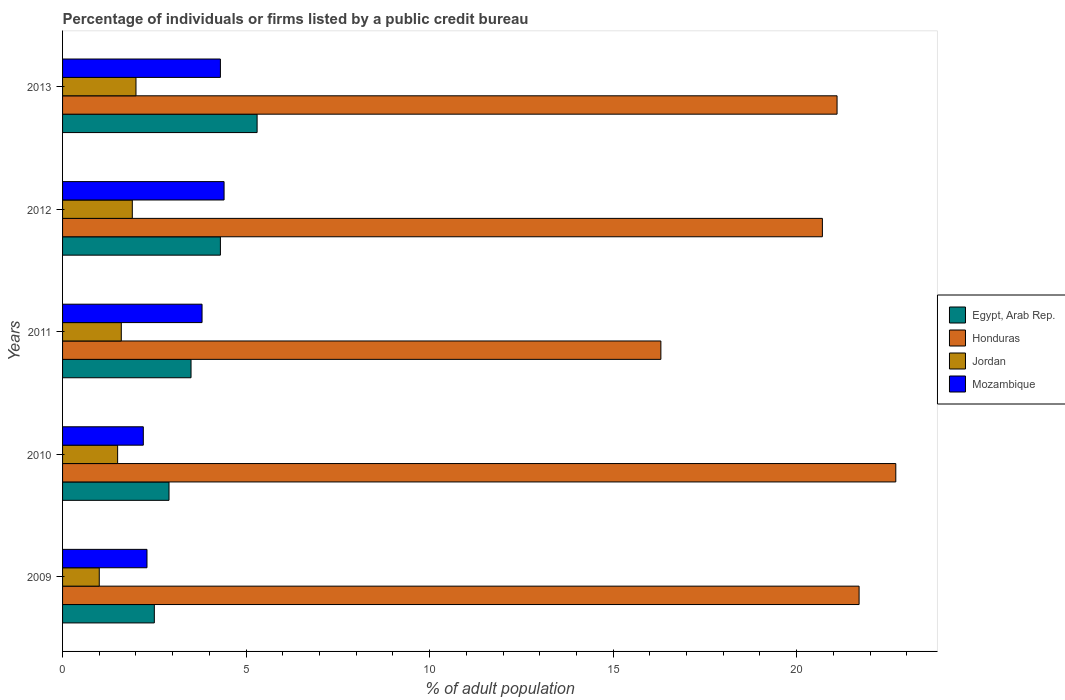How many different coloured bars are there?
Offer a terse response. 4. How many groups of bars are there?
Your answer should be very brief. 5. Are the number of bars per tick equal to the number of legend labels?
Offer a terse response. Yes. How many bars are there on the 5th tick from the bottom?
Your answer should be very brief. 4. What is the label of the 5th group of bars from the top?
Offer a very short reply. 2009. In how many cases, is the number of bars for a given year not equal to the number of legend labels?
Make the answer very short. 0. In which year was the percentage of population listed by a public credit bureau in Jordan maximum?
Make the answer very short. 2013. What is the total percentage of population listed by a public credit bureau in Egypt, Arab Rep. in the graph?
Ensure brevity in your answer.  18.5. What is the difference between the percentage of population listed by a public credit bureau in Egypt, Arab Rep. in 2010 and that in 2013?
Offer a terse response. -2.4. What is the difference between the percentage of population listed by a public credit bureau in Jordan in 2010 and the percentage of population listed by a public credit bureau in Honduras in 2013?
Provide a succinct answer. -19.6. In the year 2012, what is the difference between the percentage of population listed by a public credit bureau in Egypt, Arab Rep. and percentage of population listed by a public credit bureau in Mozambique?
Keep it short and to the point. -0.1. In how many years, is the percentage of population listed by a public credit bureau in Egypt, Arab Rep. greater than 1 %?
Give a very brief answer. 5. What is the ratio of the percentage of population listed by a public credit bureau in Honduras in 2010 to that in 2012?
Your response must be concise. 1.1. What is the difference between the highest and the second highest percentage of population listed by a public credit bureau in Egypt, Arab Rep.?
Offer a terse response. 1. What is the difference between the highest and the lowest percentage of population listed by a public credit bureau in Mozambique?
Ensure brevity in your answer.  2.2. What does the 2nd bar from the top in 2011 represents?
Provide a succinct answer. Jordan. What does the 4th bar from the bottom in 2010 represents?
Offer a very short reply. Mozambique. Is it the case that in every year, the sum of the percentage of population listed by a public credit bureau in Mozambique and percentage of population listed by a public credit bureau in Egypt, Arab Rep. is greater than the percentage of population listed by a public credit bureau in Jordan?
Give a very brief answer. Yes. How many bars are there?
Provide a short and direct response. 20. What is the difference between two consecutive major ticks on the X-axis?
Your answer should be compact. 5. Where does the legend appear in the graph?
Offer a terse response. Center right. How many legend labels are there?
Give a very brief answer. 4. What is the title of the graph?
Offer a very short reply. Percentage of individuals or firms listed by a public credit bureau. Does "Canada" appear as one of the legend labels in the graph?
Offer a terse response. No. What is the label or title of the X-axis?
Your answer should be compact. % of adult population. What is the label or title of the Y-axis?
Ensure brevity in your answer.  Years. What is the % of adult population of Egypt, Arab Rep. in 2009?
Give a very brief answer. 2.5. What is the % of adult population of Honduras in 2009?
Your answer should be very brief. 21.7. What is the % of adult population in Jordan in 2009?
Keep it short and to the point. 1. What is the % of adult population of Mozambique in 2009?
Keep it short and to the point. 2.3. What is the % of adult population of Honduras in 2010?
Your response must be concise. 22.7. What is the % of adult population of Jordan in 2010?
Give a very brief answer. 1.5. What is the % of adult population in Jordan in 2011?
Make the answer very short. 1.6. What is the % of adult population of Mozambique in 2011?
Your response must be concise. 3.8. What is the % of adult population in Honduras in 2012?
Provide a short and direct response. 20.7. What is the % of adult population in Jordan in 2012?
Provide a short and direct response. 1.9. What is the % of adult population in Honduras in 2013?
Make the answer very short. 21.1. What is the % of adult population in Jordan in 2013?
Offer a terse response. 2. What is the % of adult population of Mozambique in 2013?
Make the answer very short. 4.3. Across all years, what is the maximum % of adult population of Honduras?
Offer a terse response. 22.7. Across all years, what is the maximum % of adult population in Mozambique?
Give a very brief answer. 4.4. Across all years, what is the minimum % of adult population in Mozambique?
Make the answer very short. 2.2. What is the total % of adult population in Honduras in the graph?
Provide a succinct answer. 102.5. What is the difference between the % of adult population in Mozambique in 2009 and that in 2010?
Keep it short and to the point. 0.1. What is the difference between the % of adult population in Honduras in 2009 and that in 2011?
Offer a terse response. 5.4. What is the difference between the % of adult population of Jordan in 2009 and that in 2011?
Your response must be concise. -0.6. What is the difference between the % of adult population in Mozambique in 2009 and that in 2011?
Keep it short and to the point. -1.5. What is the difference between the % of adult population in Egypt, Arab Rep. in 2009 and that in 2012?
Keep it short and to the point. -1.8. What is the difference between the % of adult population of Honduras in 2009 and that in 2012?
Give a very brief answer. 1. What is the difference between the % of adult population in Mozambique in 2009 and that in 2012?
Ensure brevity in your answer.  -2.1. What is the difference between the % of adult population of Honduras in 2009 and that in 2013?
Give a very brief answer. 0.6. What is the difference between the % of adult population of Jordan in 2009 and that in 2013?
Make the answer very short. -1. What is the difference between the % of adult population of Mozambique in 2009 and that in 2013?
Make the answer very short. -2. What is the difference between the % of adult population of Honduras in 2010 and that in 2011?
Offer a terse response. 6.4. What is the difference between the % of adult population of Egypt, Arab Rep. in 2010 and that in 2012?
Your answer should be compact. -1.4. What is the difference between the % of adult population in Mozambique in 2010 and that in 2012?
Provide a short and direct response. -2.2. What is the difference between the % of adult population in Honduras in 2010 and that in 2013?
Give a very brief answer. 1.6. What is the difference between the % of adult population of Mozambique in 2010 and that in 2013?
Offer a terse response. -2.1. What is the difference between the % of adult population of Egypt, Arab Rep. in 2011 and that in 2012?
Keep it short and to the point. -0.8. What is the difference between the % of adult population in Honduras in 2011 and that in 2012?
Give a very brief answer. -4.4. What is the difference between the % of adult population in Honduras in 2011 and that in 2013?
Give a very brief answer. -4.8. What is the difference between the % of adult population in Jordan in 2011 and that in 2013?
Ensure brevity in your answer.  -0.4. What is the difference between the % of adult population of Mozambique in 2011 and that in 2013?
Your answer should be compact. -0.5. What is the difference between the % of adult population in Egypt, Arab Rep. in 2012 and that in 2013?
Offer a very short reply. -1. What is the difference between the % of adult population of Egypt, Arab Rep. in 2009 and the % of adult population of Honduras in 2010?
Ensure brevity in your answer.  -20.2. What is the difference between the % of adult population in Egypt, Arab Rep. in 2009 and the % of adult population in Jordan in 2010?
Provide a short and direct response. 1. What is the difference between the % of adult population in Egypt, Arab Rep. in 2009 and the % of adult population in Mozambique in 2010?
Make the answer very short. 0.3. What is the difference between the % of adult population of Honduras in 2009 and the % of adult population of Jordan in 2010?
Your response must be concise. 20.2. What is the difference between the % of adult population in Honduras in 2009 and the % of adult population in Mozambique in 2010?
Your response must be concise. 19.5. What is the difference between the % of adult population of Egypt, Arab Rep. in 2009 and the % of adult population of Honduras in 2011?
Offer a very short reply. -13.8. What is the difference between the % of adult population of Egypt, Arab Rep. in 2009 and the % of adult population of Mozambique in 2011?
Offer a very short reply. -1.3. What is the difference between the % of adult population in Honduras in 2009 and the % of adult population in Jordan in 2011?
Ensure brevity in your answer.  20.1. What is the difference between the % of adult population in Egypt, Arab Rep. in 2009 and the % of adult population in Honduras in 2012?
Offer a terse response. -18.2. What is the difference between the % of adult population of Egypt, Arab Rep. in 2009 and the % of adult population of Jordan in 2012?
Make the answer very short. 0.6. What is the difference between the % of adult population in Honduras in 2009 and the % of adult population in Jordan in 2012?
Provide a short and direct response. 19.8. What is the difference between the % of adult population in Egypt, Arab Rep. in 2009 and the % of adult population in Honduras in 2013?
Provide a succinct answer. -18.6. What is the difference between the % of adult population in Egypt, Arab Rep. in 2009 and the % of adult population in Jordan in 2013?
Offer a terse response. 0.5. What is the difference between the % of adult population in Egypt, Arab Rep. in 2009 and the % of adult population in Mozambique in 2013?
Give a very brief answer. -1.8. What is the difference between the % of adult population in Honduras in 2009 and the % of adult population in Mozambique in 2013?
Ensure brevity in your answer.  17.4. What is the difference between the % of adult population of Jordan in 2009 and the % of adult population of Mozambique in 2013?
Give a very brief answer. -3.3. What is the difference between the % of adult population in Egypt, Arab Rep. in 2010 and the % of adult population in Jordan in 2011?
Offer a very short reply. 1.3. What is the difference between the % of adult population of Honduras in 2010 and the % of adult population of Jordan in 2011?
Provide a short and direct response. 21.1. What is the difference between the % of adult population of Egypt, Arab Rep. in 2010 and the % of adult population of Honduras in 2012?
Offer a terse response. -17.8. What is the difference between the % of adult population in Egypt, Arab Rep. in 2010 and the % of adult population in Jordan in 2012?
Provide a short and direct response. 1. What is the difference between the % of adult population of Honduras in 2010 and the % of adult population of Jordan in 2012?
Offer a terse response. 20.8. What is the difference between the % of adult population of Egypt, Arab Rep. in 2010 and the % of adult population of Honduras in 2013?
Offer a very short reply. -18.2. What is the difference between the % of adult population in Egypt, Arab Rep. in 2010 and the % of adult population in Jordan in 2013?
Keep it short and to the point. 0.9. What is the difference between the % of adult population in Egypt, Arab Rep. in 2010 and the % of adult population in Mozambique in 2013?
Offer a terse response. -1.4. What is the difference between the % of adult population in Honduras in 2010 and the % of adult population in Jordan in 2013?
Your response must be concise. 20.7. What is the difference between the % of adult population of Egypt, Arab Rep. in 2011 and the % of adult population of Honduras in 2012?
Provide a succinct answer. -17.2. What is the difference between the % of adult population of Egypt, Arab Rep. in 2011 and the % of adult population of Jordan in 2012?
Your response must be concise. 1.6. What is the difference between the % of adult population in Egypt, Arab Rep. in 2011 and the % of adult population in Mozambique in 2012?
Keep it short and to the point. -0.9. What is the difference between the % of adult population in Honduras in 2011 and the % of adult population in Jordan in 2012?
Give a very brief answer. 14.4. What is the difference between the % of adult population in Honduras in 2011 and the % of adult population in Mozambique in 2012?
Offer a terse response. 11.9. What is the difference between the % of adult population in Jordan in 2011 and the % of adult population in Mozambique in 2012?
Give a very brief answer. -2.8. What is the difference between the % of adult population of Egypt, Arab Rep. in 2011 and the % of adult population of Honduras in 2013?
Your answer should be very brief. -17.6. What is the difference between the % of adult population in Egypt, Arab Rep. in 2011 and the % of adult population in Jordan in 2013?
Your response must be concise. 1.5. What is the difference between the % of adult population of Egypt, Arab Rep. in 2011 and the % of adult population of Mozambique in 2013?
Your answer should be very brief. -0.8. What is the difference between the % of adult population of Honduras in 2011 and the % of adult population of Jordan in 2013?
Provide a short and direct response. 14.3. What is the difference between the % of adult population in Honduras in 2011 and the % of adult population in Mozambique in 2013?
Provide a succinct answer. 12. What is the difference between the % of adult population in Egypt, Arab Rep. in 2012 and the % of adult population in Honduras in 2013?
Provide a short and direct response. -16.8. What is the difference between the % of adult population of Egypt, Arab Rep. in 2012 and the % of adult population of Jordan in 2013?
Offer a terse response. 2.3. What is the difference between the % of adult population in Egypt, Arab Rep. in 2012 and the % of adult population in Mozambique in 2013?
Give a very brief answer. 0. What is the average % of adult population in Honduras per year?
Give a very brief answer. 20.5. What is the average % of adult population in Mozambique per year?
Your response must be concise. 3.4. In the year 2009, what is the difference between the % of adult population in Egypt, Arab Rep. and % of adult population in Honduras?
Give a very brief answer. -19.2. In the year 2009, what is the difference between the % of adult population of Egypt, Arab Rep. and % of adult population of Mozambique?
Your response must be concise. 0.2. In the year 2009, what is the difference between the % of adult population of Honduras and % of adult population of Jordan?
Your answer should be very brief. 20.7. In the year 2009, what is the difference between the % of adult population of Honduras and % of adult population of Mozambique?
Make the answer very short. 19.4. In the year 2009, what is the difference between the % of adult population of Jordan and % of adult population of Mozambique?
Offer a terse response. -1.3. In the year 2010, what is the difference between the % of adult population in Egypt, Arab Rep. and % of adult population in Honduras?
Your response must be concise. -19.8. In the year 2010, what is the difference between the % of adult population in Honduras and % of adult population in Jordan?
Ensure brevity in your answer.  21.2. In the year 2010, what is the difference between the % of adult population of Jordan and % of adult population of Mozambique?
Your answer should be compact. -0.7. In the year 2011, what is the difference between the % of adult population in Egypt, Arab Rep. and % of adult population in Honduras?
Your answer should be very brief. -12.8. In the year 2011, what is the difference between the % of adult population of Honduras and % of adult population of Jordan?
Your answer should be compact. 14.7. In the year 2011, what is the difference between the % of adult population in Honduras and % of adult population in Mozambique?
Provide a short and direct response. 12.5. In the year 2011, what is the difference between the % of adult population of Jordan and % of adult population of Mozambique?
Keep it short and to the point. -2.2. In the year 2012, what is the difference between the % of adult population in Egypt, Arab Rep. and % of adult population in Honduras?
Offer a terse response. -16.4. In the year 2012, what is the difference between the % of adult population in Egypt, Arab Rep. and % of adult population in Mozambique?
Your answer should be very brief. -0.1. In the year 2012, what is the difference between the % of adult population of Honduras and % of adult population of Jordan?
Your response must be concise. 18.8. In the year 2013, what is the difference between the % of adult population in Egypt, Arab Rep. and % of adult population in Honduras?
Provide a succinct answer. -15.8. In the year 2013, what is the difference between the % of adult population in Egypt, Arab Rep. and % of adult population in Mozambique?
Ensure brevity in your answer.  1. In the year 2013, what is the difference between the % of adult population in Honduras and % of adult population in Jordan?
Your answer should be very brief. 19.1. In the year 2013, what is the difference between the % of adult population of Honduras and % of adult population of Mozambique?
Give a very brief answer. 16.8. In the year 2013, what is the difference between the % of adult population in Jordan and % of adult population in Mozambique?
Provide a succinct answer. -2.3. What is the ratio of the % of adult population in Egypt, Arab Rep. in 2009 to that in 2010?
Your response must be concise. 0.86. What is the ratio of the % of adult population in Honduras in 2009 to that in 2010?
Ensure brevity in your answer.  0.96. What is the ratio of the % of adult population in Jordan in 2009 to that in 2010?
Give a very brief answer. 0.67. What is the ratio of the % of adult population in Mozambique in 2009 to that in 2010?
Your answer should be compact. 1.05. What is the ratio of the % of adult population of Egypt, Arab Rep. in 2009 to that in 2011?
Your answer should be compact. 0.71. What is the ratio of the % of adult population of Honduras in 2009 to that in 2011?
Keep it short and to the point. 1.33. What is the ratio of the % of adult population in Mozambique in 2009 to that in 2011?
Offer a terse response. 0.61. What is the ratio of the % of adult population of Egypt, Arab Rep. in 2009 to that in 2012?
Your answer should be compact. 0.58. What is the ratio of the % of adult population in Honduras in 2009 to that in 2012?
Provide a short and direct response. 1.05. What is the ratio of the % of adult population of Jordan in 2009 to that in 2012?
Keep it short and to the point. 0.53. What is the ratio of the % of adult population of Mozambique in 2009 to that in 2012?
Your answer should be very brief. 0.52. What is the ratio of the % of adult population of Egypt, Arab Rep. in 2009 to that in 2013?
Your answer should be very brief. 0.47. What is the ratio of the % of adult population in Honduras in 2009 to that in 2013?
Give a very brief answer. 1.03. What is the ratio of the % of adult population of Jordan in 2009 to that in 2013?
Your answer should be very brief. 0.5. What is the ratio of the % of adult population of Mozambique in 2009 to that in 2013?
Ensure brevity in your answer.  0.53. What is the ratio of the % of adult population in Egypt, Arab Rep. in 2010 to that in 2011?
Your response must be concise. 0.83. What is the ratio of the % of adult population in Honduras in 2010 to that in 2011?
Make the answer very short. 1.39. What is the ratio of the % of adult population in Mozambique in 2010 to that in 2011?
Provide a short and direct response. 0.58. What is the ratio of the % of adult population in Egypt, Arab Rep. in 2010 to that in 2012?
Offer a terse response. 0.67. What is the ratio of the % of adult population in Honduras in 2010 to that in 2012?
Provide a short and direct response. 1.1. What is the ratio of the % of adult population of Jordan in 2010 to that in 2012?
Your answer should be compact. 0.79. What is the ratio of the % of adult population of Mozambique in 2010 to that in 2012?
Give a very brief answer. 0.5. What is the ratio of the % of adult population of Egypt, Arab Rep. in 2010 to that in 2013?
Provide a succinct answer. 0.55. What is the ratio of the % of adult population in Honduras in 2010 to that in 2013?
Your response must be concise. 1.08. What is the ratio of the % of adult population in Jordan in 2010 to that in 2013?
Provide a succinct answer. 0.75. What is the ratio of the % of adult population in Mozambique in 2010 to that in 2013?
Your response must be concise. 0.51. What is the ratio of the % of adult population of Egypt, Arab Rep. in 2011 to that in 2012?
Offer a very short reply. 0.81. What is the ratio of the % of adult population in Honduras in 2011 to that in 2012?
Offer a terse response. 0.79. What is the ratio of the % of adult population of Jordan in 2011 to that in 2012?
Give a very brief answer. 0.84. What is the ratio of the % of adult population of Mozambique in 2011 to that in 2012?
Your response must be concise. 0.86. What is the ratio of the % of adult population of Egypt, Arab Rep. in 2011 to that in 2013?
Make the answer very short. 0.66. What is the ratio of the % of adult population in Honduras in 2011 to that in 2013?
Provide a short and direct response. 0.77. What is the ratio of the % of adult population of Jordan in 2011 to that in 2013?
Offer a very short reply. 0.8. What is the ratio of the % of adult population in Mozambique in 2011 to that in 2013?
Give a very brief answer. 0.88. What is the ratio of the % of adult population of Egypt, Arab Rep. in 2012 to that in 2013?
Your answer should be very brief. 0.81. What is the ratio of the % of adult population of Mozambique in 2012 to that in 2013?
Ensure brevity in your answer.  1.02. What is the difference between the highest and the second highest % of adult population of Jordan?
Make the answer very short. 0.1. What is the difference between the highest and the second highest % of adult population in Mozambique?
Provide a short and direct response. 0.1. What is the difference between the highest and the lowest % of adult population of Egypt, Arab Rep.?
Offer a very short reply. 2.8. What is the difference between the highest and the lowest % of adult population of Honduras?
Offer a terse response. 6.4. What is the difference between the highest and the lowest % of adult population in Mozambique?
Keep it short and to the point. 2.2. 